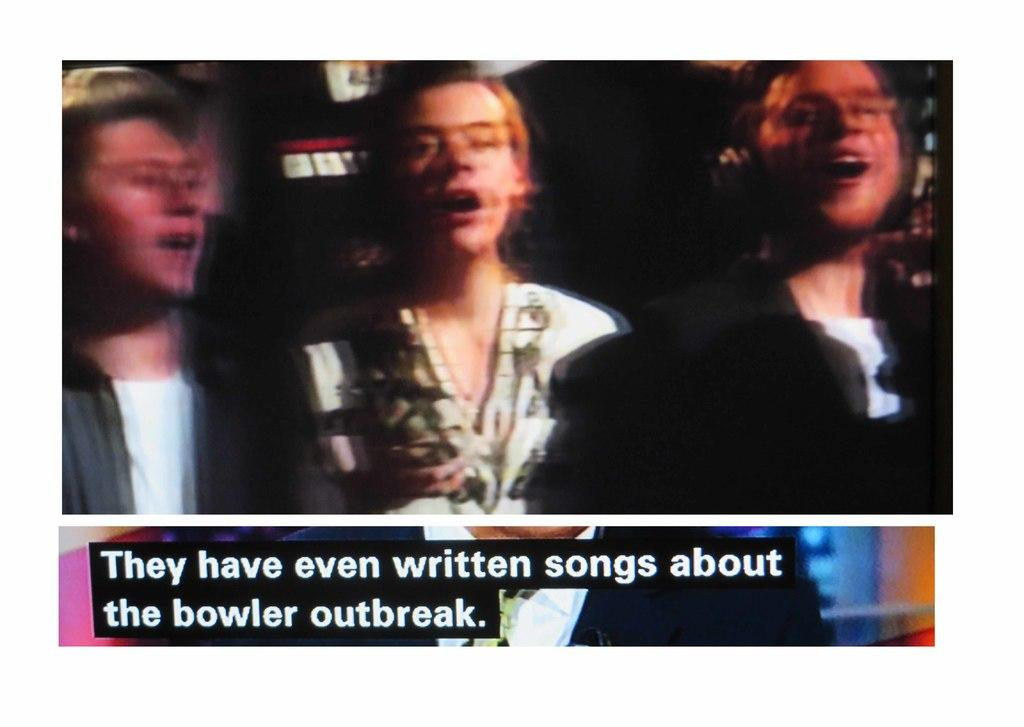What is the quality of the image? The image is blurry. Can you confirm the number of people in the image? No, due to the blurriness, it cannot be confirmed if there are three people in the image. Is there any text visible below the picture? No, due to the blurriness, it cannot be confirmed if there is a statement below the picture. What type of soup is being served in the image? There is no soup present in the image, as it is blurry and difficult to discern specific details. 